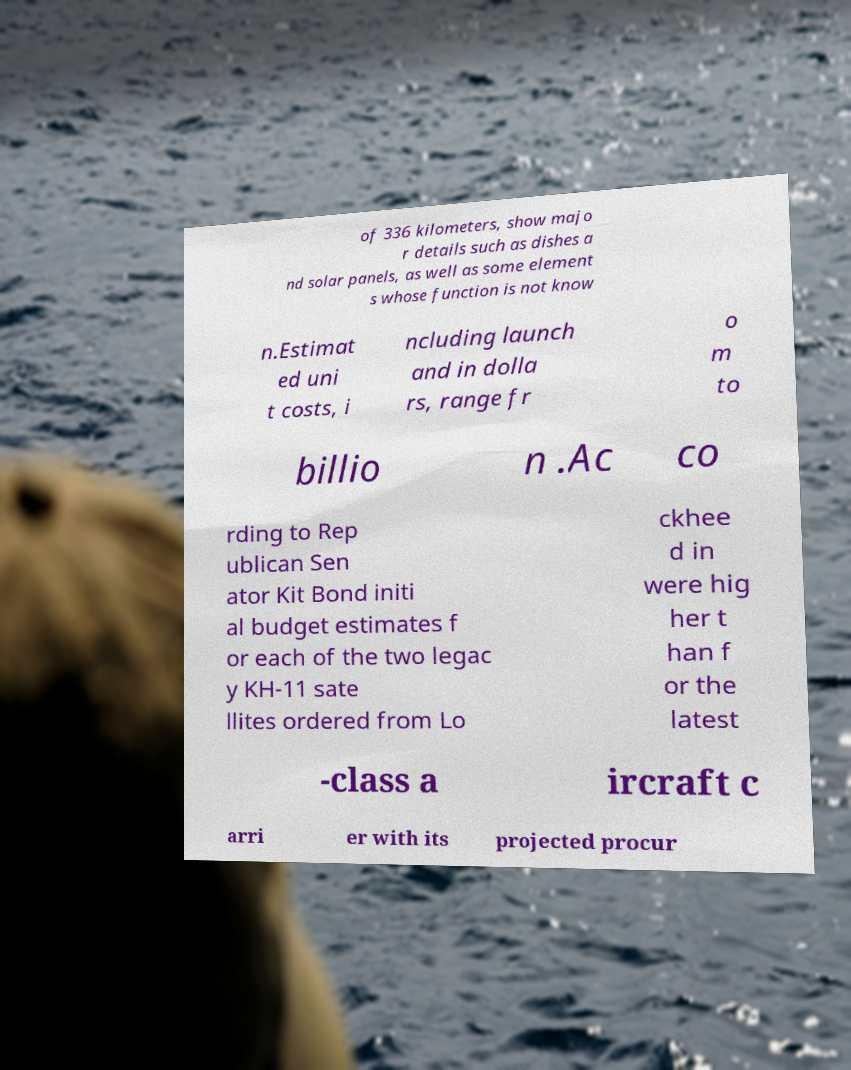Could you assist in decoding the text presented in this image and type it out clearly? of 336 kilometers, show majo r details such as dishes a nd solar panels, as well as some element s whose function is not know n.Estimat ed uni t costs, i ncluding launch and in dolla rs, range fr o m to billio n .Ac co rding to Rep ublican Sen ator Kit Bond initi al budget estimates f or each of the two legac y KH-11 sate llites ordered from Lo ckhee d in were hig her t han f or the latest -class a ircraft c arri er with its projected procur 